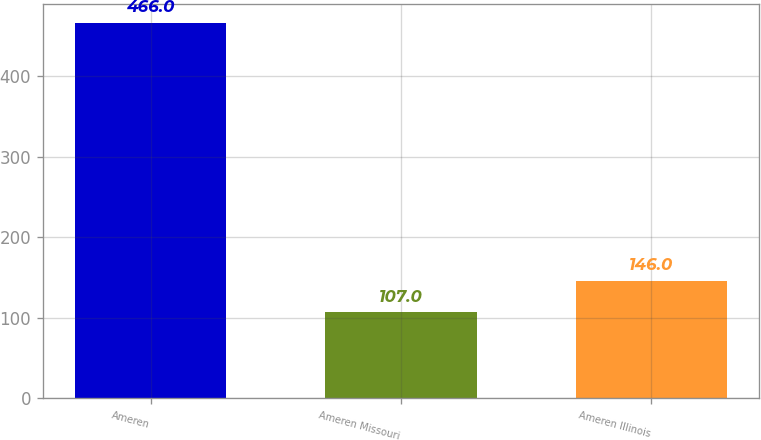<chart> <loc_0><loc_0><loc_500><loc_500><bar_chart><fcel>Ameren<fcel>Ameren Missouri<fcel>Ameren Illinois<nl><fcel>466<fcel>107<fcel>146<nl></chart> 